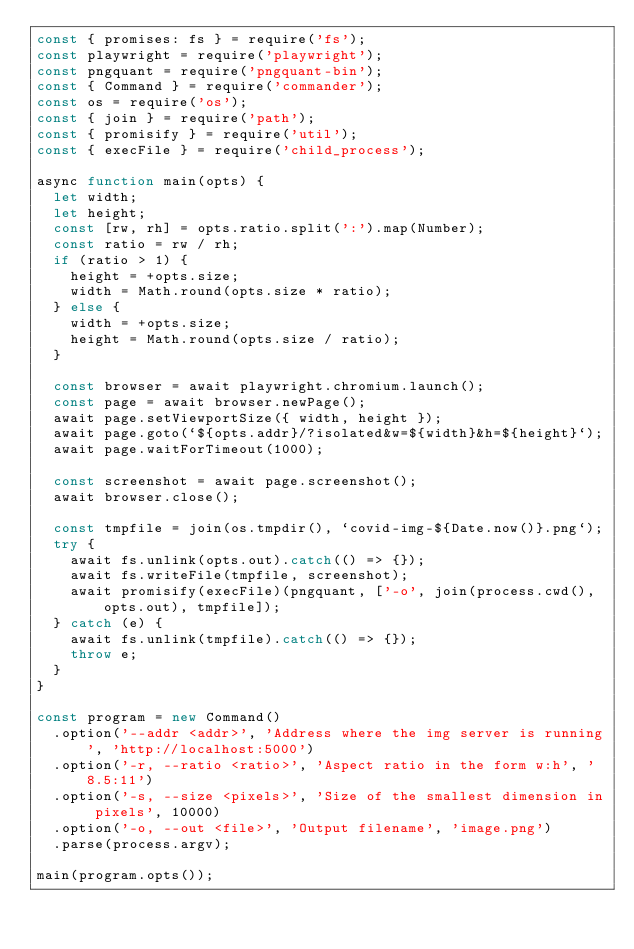<code> <loc_0><loc_0><loc_500><loc_500><_JavaScript_>const { promises: fs } = require('fs');
const playwright = require('playwright');
const pngquant = require('pngquant-bin');
const { Command } = require('commander');
const os = require('os');
const { join } = require('path');
const { promisify } = require('util');
const { execFile } = require('child_process');

async function main(opts) {
  let width;
  let height;
  const [rw, rh] = opts.ratio.split(':').map(Number);
  const ratio = rw / rh;
  if (ratio > 1) {
    height = +opts.size;
    width = Math.round(opts.size * ratio);
  } else {
    width = +opts.size;
    height = Math.round(opts.size / ratio);
  }

  const browser = await playwright.chromium.launch();
  const page = await browser.newPage();
  await page.setViewportSize({ width, height });
  await page.goto(`${opts.addr}/?isolated&w=${width}&h=${height}`);
  await page.waitForTimeout(1000);

  const screenshot = await page.screenshot();
  await browser.close();

  const tmpfile = join(os.tmpdir(), `covid-img-${Date.now()}.png`);
  try {
    await fs.unlink(opts.out).catch(() => {});
    await fs.writeFile(tmpfile, screenshot);
    await promisify(execFile)(pngquant, ['-o', join(process.cwd(), opts.out), tmpfile]);
  } catch (e) {
    await fs.unlink(tmpfile).catch(() => {});
    throw e;
  }
}

const program = new Command()
  .option('--addr <addr>', 'Address where the img server is running', 'http://localhost:5000')
  .option('-r, --ratio <ratio>', 'Aspect ratio in the form w:h', '8.5:11')
  .option('-s, --size <pixels>', 'Size of the smallest dimension in pixels', 10000)
  .option('-o, --out <file>', 'Output filename', 'image.png')
  .parse(process.argv);

main(program.opts());
</code> 